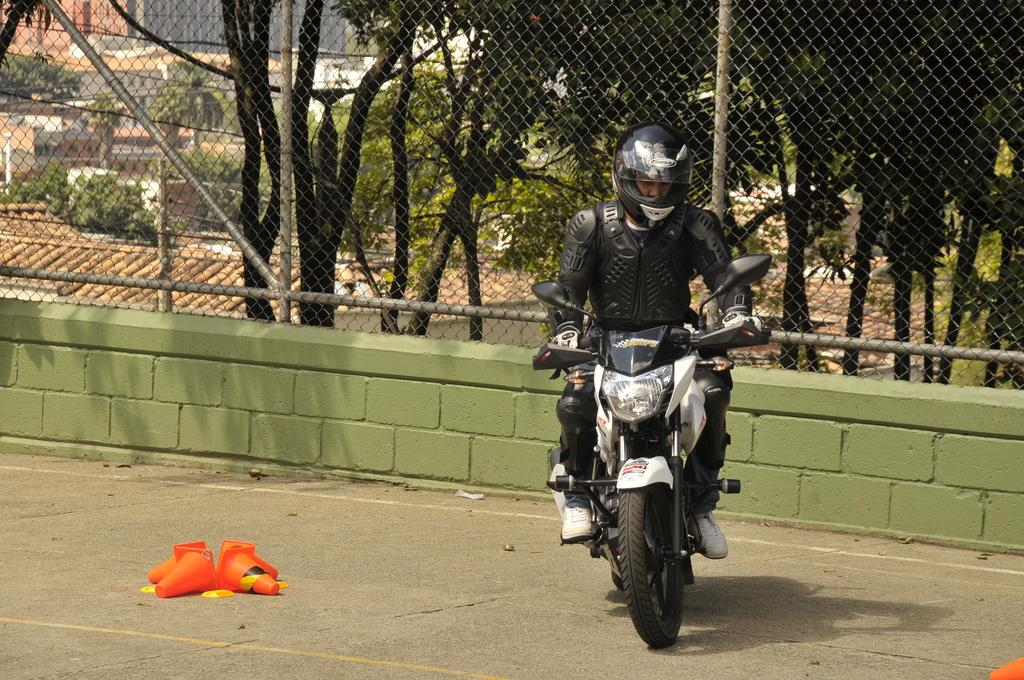What is the man doing in the image? The man is riding a bike in the image. Where is the man riding the bike? The man is on the road in the image. What can be seen on the road in the image? There are poles on the road in the image. What is visible in the background of the image? There is a wall, a railing, a tree, a building, and the sky visible in the background of the image. What type of crown is the man wearing while riding the bike in the image? There is no crown present in the image; the man is not wearing any headgear. 